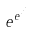Convert formula to latex. <formula><loc_0><loc_0><loc_500><loc_500>e ^ { e ^ { \cdot ^ { \cdot ^ { \cdot } } } }</formula> 